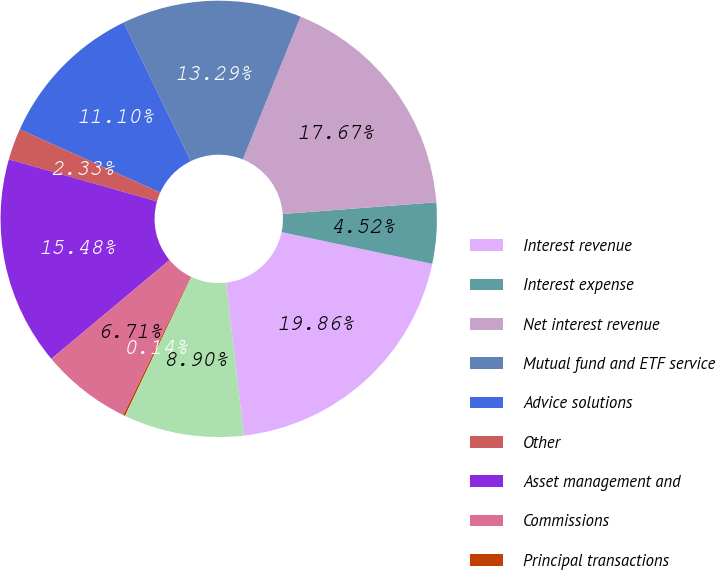Convert chart. <chart><loc_0><loc_0><loc_500><loc_500><pie_chart><fcel>Interest revenue<fcel>Interest expense<fcel>Net interest revenue<fcel>Mutual fund and ETF service<fcel>Advice solutions<fcel>Other<fcel>Asset management and<fcel>Commissions<fcel>Principal transactions<fcel>Trading revenue<nl><fcel>19.86%<fcel>4.52%<fcel>17.67%<fcel>13.29%<fcel>11.1%<fcel>2.33%<fcel>15.48%<fcel>6.71%<fcel>0.14%<fcel>8.9%<nl></chart> 